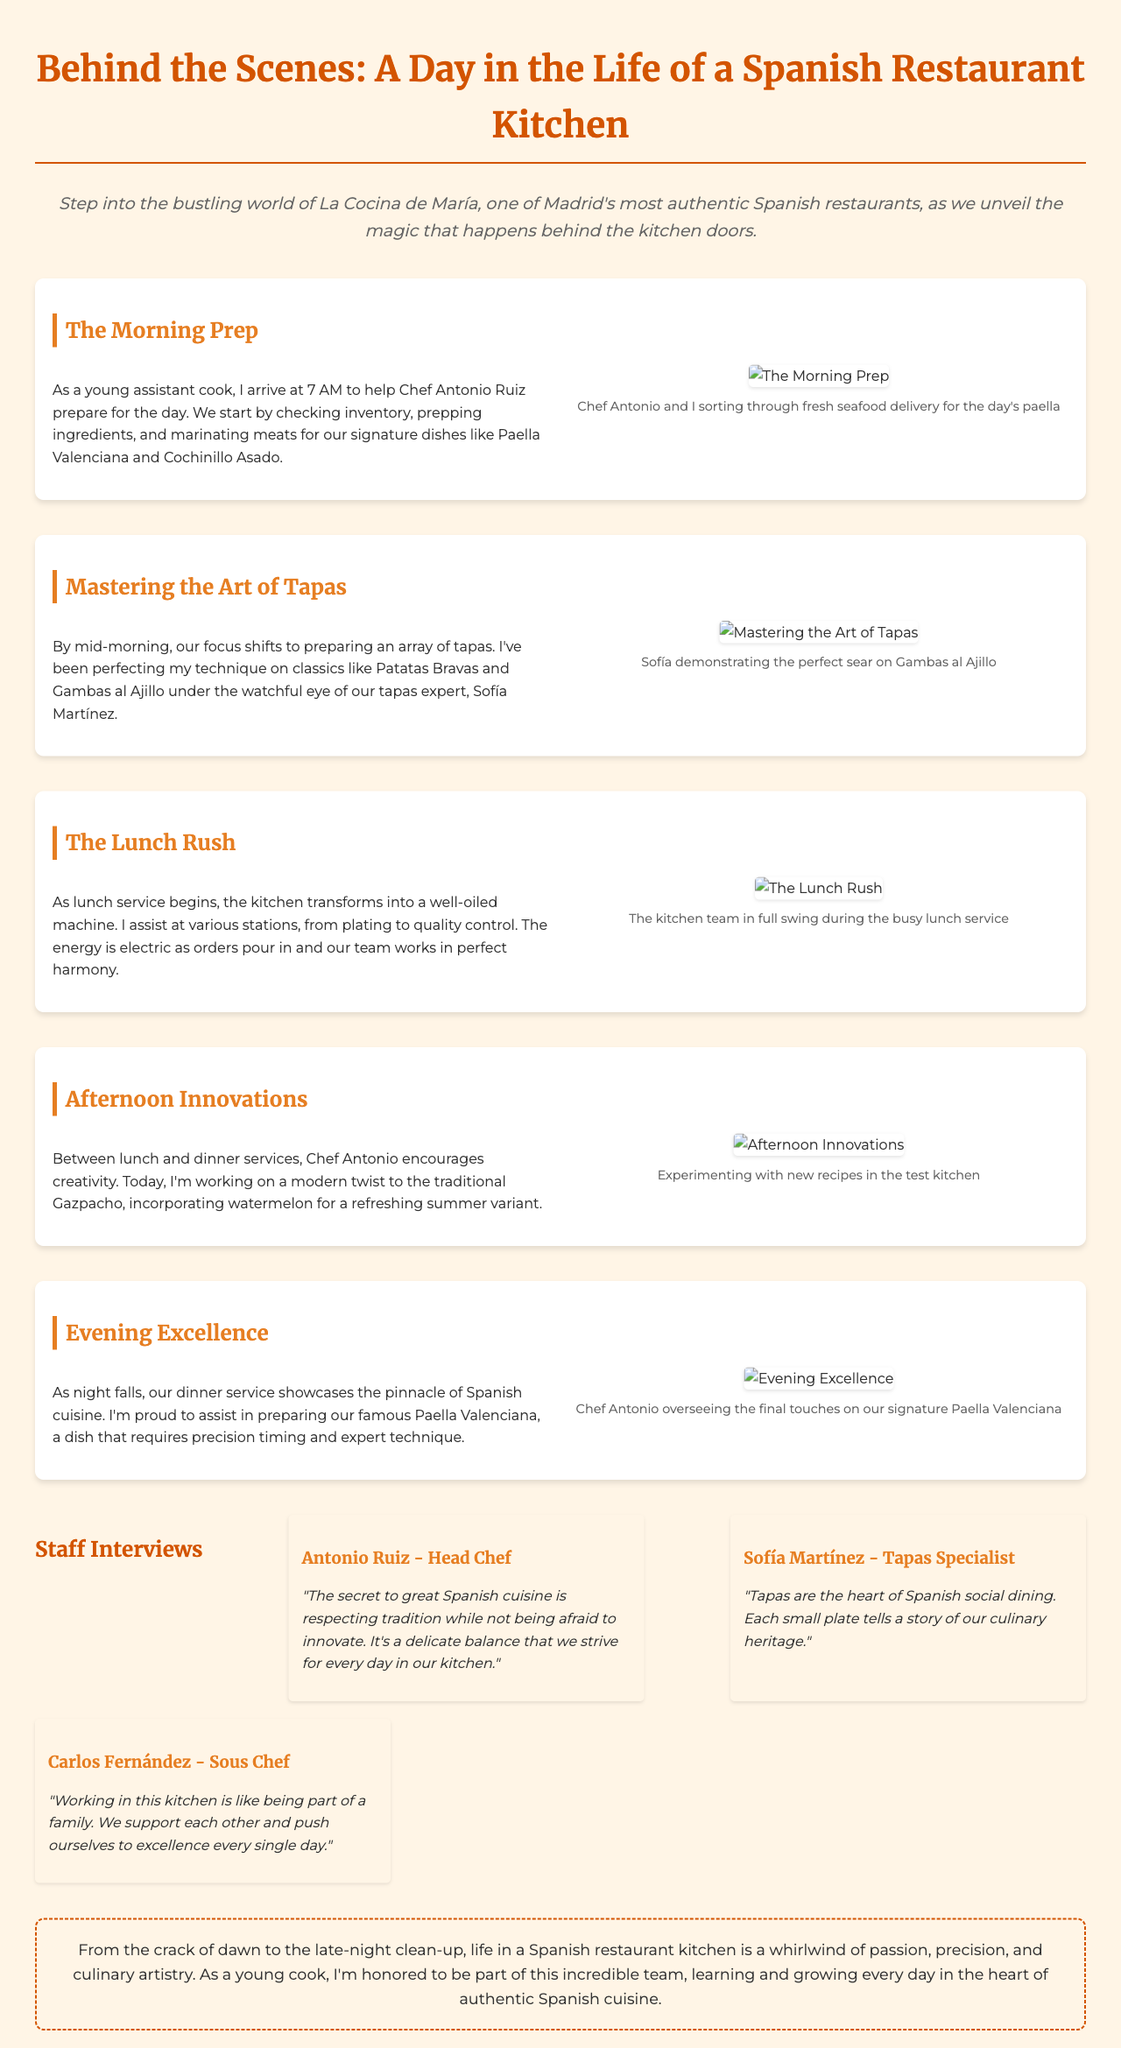What time does the kitchen staff arrive for morning prep? The document states that the young assistant cook arrives at 7 AM to help with preparation.
Answer: 7 AM Who oversees the tapas preparation? The newsletter mentions that the tapas expert, Sofía Martínez, supervises the preparation of tapas.
Answer: Sofía Martínez What dish is being prepared with a modern twist? The afternoon section indicates that the assistant is working on a modern version of Gazpacho, incorporating watermelon.
Answer: Gazpacho What is Chef Antonio's position? The staff interview identifies Antonio Ruiz as the Head Chef of La Cocina de María.
Answer: Head Chef What is the role of Carlos Fernández in the kitchen? According to the interviews, Carlos Fernández is the Sous Chef.
Answer: Sous Chef What dish requires precision timing and expert technique? The document specifies that the famous Paella Valenciana requires precision timing and expertise in its preparation.
Answer: Paella Valenciana What is emphasized as the heart of Spanish social dining? The section on mastering tapas notes that tapas are considered the heart of Spanish social dining.
Answer: Tapas How does the evening service showcase Spanish cuisine? The conclusion highlights that the dinner service showcases the pinnacle of Spanish cuisine.
Answer: Pinnacle of Spanish cuisine 